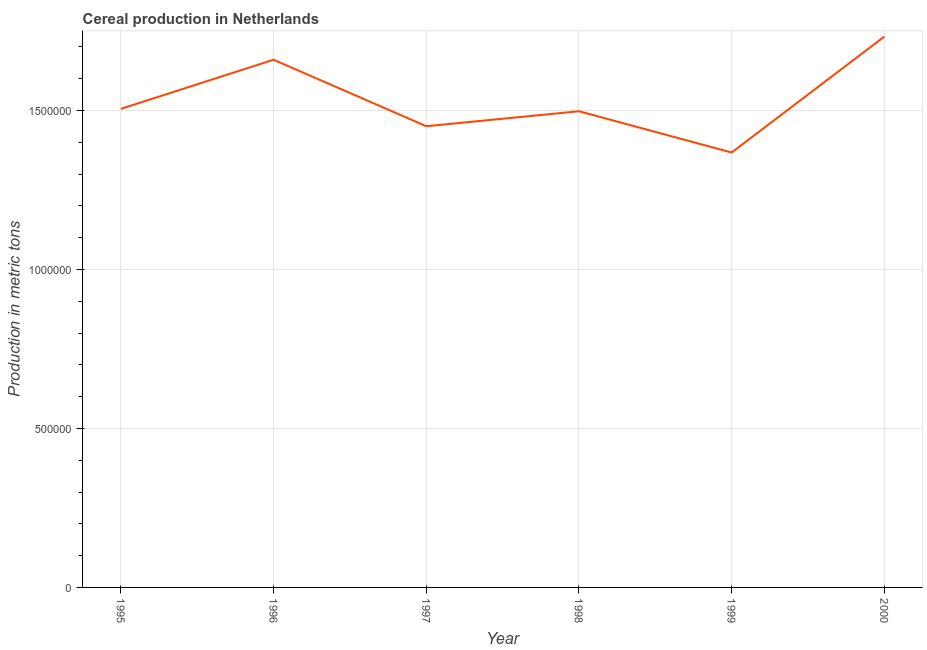What is the cereal production in 2000?
Your response must be concise. 1.73e+06. Across all years, what is the maximum cereal production?
Provide a short and direct response. 1.73e+06. Across all years, what is the minimum cereal production?
Provide a succinct answer. 1.37e+06. What is the sum of the cereal production?
Offer a terse response. 9.21e+06. What is the difference between the cereal production in 1995 and 1998?
Your answer should be very brief. 7500. What is the average cereal production per year?
Provide a succinct answer. 1.54e+06. What is the median cereal production?
Provide a succinct answer. 1.50e+06. What is the ratio of the cereal production in 1995 to that in 1998?
Your response must be concise. 1.01. Is the cereal production in 1997 less than that in 1999?
Your response must be concise. No. What is the difference between the highest and the second highest cereal production?
Provide a short and direct response. 7.27e+04. Is the sum of the cereal production in 1995 and 1997 greater than the maximum cereal production across all years?
Provide a short and direct response. Yes. What is the difference between the highest and the lowest cereal production?
Your response must be concise. 3.64e+05. Does the cereal production monotonically increase over the years?
Make the answer very short. No. How many years are there in the graph?
Give a very brief answer. 6. What is the difference between two consecutive major ticks on the Y-axis?
Provide a short and direct response. 5.00e+05. Are the values on the major ticks of Y-axis written in scientific E-notation?
Provide a succinct answer. No. Does the graph contain any zero values?
Your response must be concise. No. What is the title of the graph?
Give a very brief answer. Cereal production in Netherlands. What is the label or title of the X-axis?
Offer a terse response. Year. What is the label or title of the Y-axis?
Provide a succinct answer. Production in metric tons. What is the Production in metric tons of 1995?
Offer a terse response. 1.50e+06. What is the Production in metric tons of 1996?
Make the answer very short. 1.66e+06. What is the Production in metric tons of 1997?
Your answer should be very brief. 1.45e+06. What is the Production in metric tons of 1998?
Your response must be concise. 1.50e+06. What is the Production in metric tons of 1999?
Provide a short and direct response. 1.37e+06. What is the Production in metric tons in 2000?
Provide a short and direct response. 1.73e+06. What is the difference between the Production in metric tons in 1995 and 1996?
Your response must be concise. -1.54e+05. What is the difference between the Production in metric tons in 1995 and 1997?
Your answer should be compact. 5.46e+04. What is the difference between the Production in metric tons in 1995 and 1998?
Offer a terse response. 7500. What is the difference between the Production in metric tons in 1995 and 1999?
Offer a very short reply. 1.37e+05. What is the difference between the Production in metric tons in 1995 and 2000?
Ensure brevity in your answer.  -2.27e+05. What is the difference between the Production in metric tons in 1996 and 1997?
Your response must be concise. 2.09e+05. What is the difference between the Production in metric tons in 1996 and 1998?
Ensure brevity in your answer.  1.62e+05. What is the difference between the Production in metric tons in 1996 and 1999?
Provide a short and direct response. 2.92e+05. What is the difference between the Production in metric tons in 1996 and 2000?
Make the answer very short. -7.27e+04. What is the difference between the Production in metric tons in 1997 and 1998?
Offer a terse response. -4.71e+04. What is the difference between the Production in metric tons in 1997 and 1999?
Provide a succinct answer. 8.27e+04. What is the difference between the Production in metric tons in 1997 and 2000?
Your answer should be very brief. -2.82e+05. What is the difference between the Production in metric tons in 1998 and 1999?
Your answer should be compact. 1.30e+05. What is the difference between the Production in metric tons in 1998 and 2000?
Make the answer very short. -2.35e+05. What is the difference between the Production in metric tons in 1999 and 2000?
Provide a succinct answer. -3.64e+05. What is the ratio of the Production in metric tons in 1995 to that in 1996?
Keep it short and to the point. 0.91. What is the ratio of the Production in metric tons in 1995 to that in 1997?
Offer a very short reply. 1.04. What is the ratio of the Production in metric tons in 1995 to that in 1999?
Your answer should be very brief. 1.1. What is the ratio of the Production in metric tons in 1995 to that in 2000?
Provide a short and direct response. 0.87. What is the ratio of the Production in metric tons in 1996 to that in 1997?
Your response must be concise. 1.14. What is the ratio of the Production in metric tons in 1996 to that in 1998?
Keep it short and to the point. 1.11. What is the ratio of the Production in metric tons in 1996 to that in 1999?
Your answer should be compact. 1.21. What is the ratio of the Production in metric tons in 1996 to that in 2000?
Offer a terse response. 0.96. What is the ratio of the Production in metric tons in 1997 to that in 1998?
Provide a short and direct response. 0.97. What is the ratio of the Production in metric tons in 1997 to that in 1999?
Keep it short and to the point. 1.06. What is the ratio of the Production in metric tons in 1997 to that in 2000?
Keep it short and to the point. 0.84. What is the ratio of the Production in metric tons in 1998 to that in 1999?
Your answer should be very brief. 1.09. What is the ratio of the Production in metric tons in 1998 to that in 2000?
Offer a very short reply. 0.86. What is the ratio of the Production in metric tons in 1999 to that in 2000?
Your answer should be very brief. 0.79. 